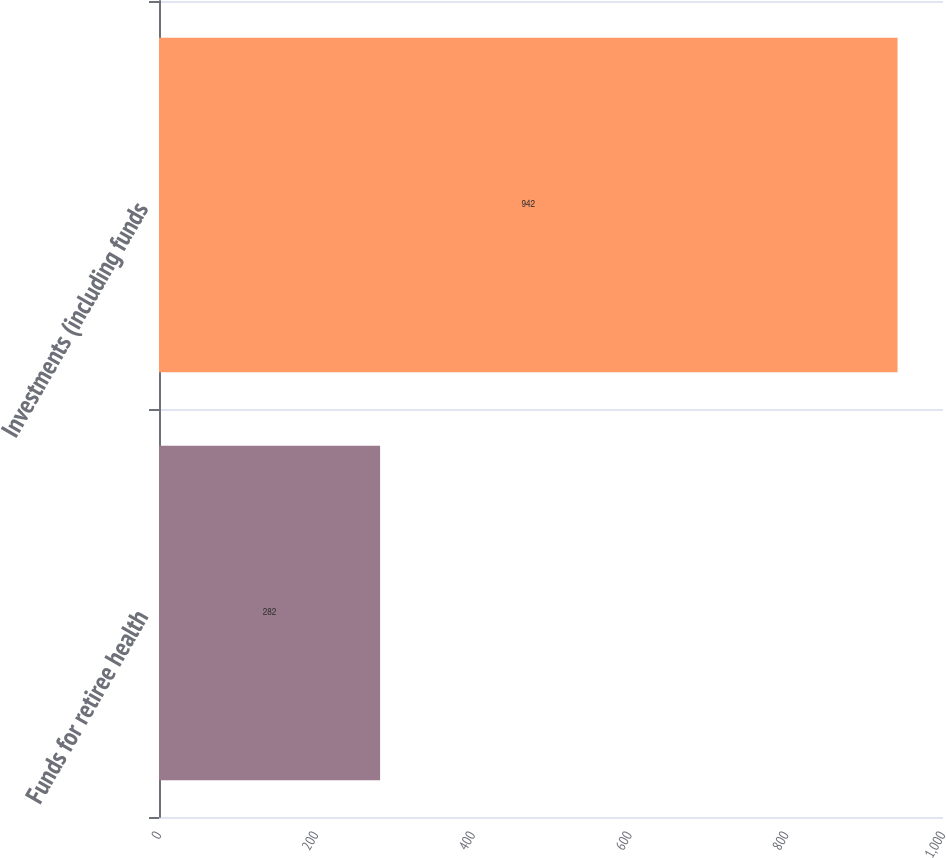<chart> <loc_0><loc_0><loc_500><loc_500><bar_chart><fcel>Funds for retiree health<fcel>Investments (including funds<nl><fcel>282<fcel>942<nl></chart> 